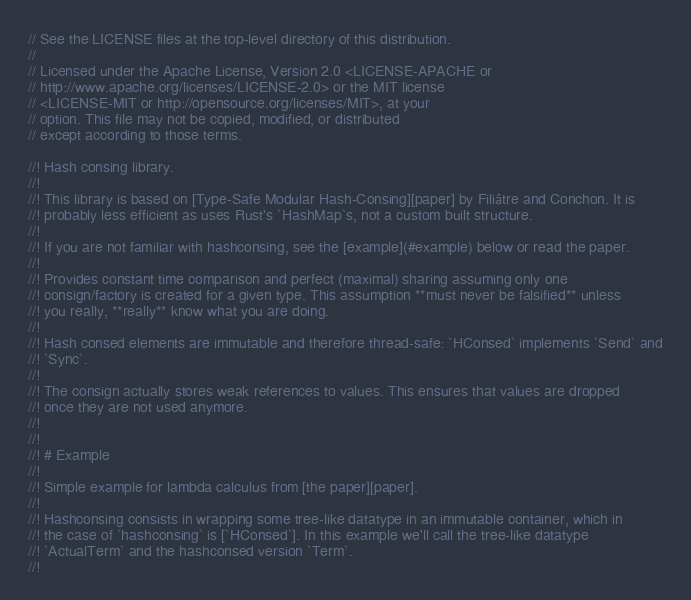<code> <loc_0><loc_0><loc_500><loc_500><_Rust_>// See the LICENSE files at the top-level directory of this distribution.
//
// Licensed under the Apache License, Version 2.0 <LICENSE-APACHE or
// http://www.apache.org/licenses/LICENSE-2.0> or the MIT license
// <LICENSE-MIT or http://opensource.org/licenses/MIT>, at your
// option. This file may not be copied, modified, or distributed
// except according to those terms.

//! Hash consing library.
//!
//! This library is based on [Type-Safe Modular Hash-Consing][paper] by Filiâtre and Conchon. It is
//! probably less efficient as uses Rust's `HashMap`s, not a custom built structure.
//!
//! If you are not familiar with hashconsing, see the [example](#example) below or read the paper.
//!
//! Provides constant time comparison and perfect (maximal) sharing assuming only one
//! consign/factory is created for a given type. This assumption **must never be falsified** unless
//! you really, **really** know what you are doing.
//!
//! Hash consed elements are immutable and therefore thread-safe: `HConsed` implements `Send` and
//! `Sync`.
//!
//! The consign actually stores weak references to values. This ensures that values are dropped
//! once they are not used anymore.
//!
//!
//! # Example
//!
//! Simple example for lambda calculus from [the paper][paper].
//!
//! Hashconsing consists in wrapping some tree-like datatype in an immutable container, which in
//! the case of `hashconsing` is [`HConsed`]. In this example we'll call the tree-like datatype
//! `ActualTerm` and the hashconsed version `Term`.
//!</code> 